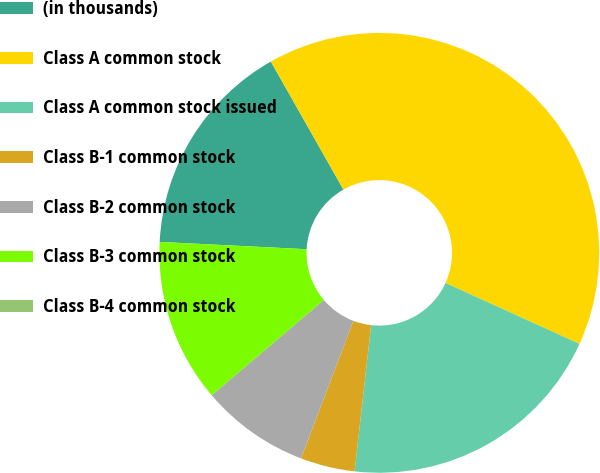Convert chart to OTSL. <chart><loc_0><loc_0><loc_500><loc_500><pie_chart><fcel>(in thousands)<fcel>Class A common stock<fcel>Class A common stock issued<fcel>Class B-1 common stock<fcel>Class B-2 common stock<fcel>Class B-3 common stock<fcel>Class B-4 common stock<nl><fcel>16.0%<fcel>40.0%<fcel>20.0%<fcel>4.0%<fcel>8.0%<fcel>12.0%<fcel>0.0%<nl></chart> 